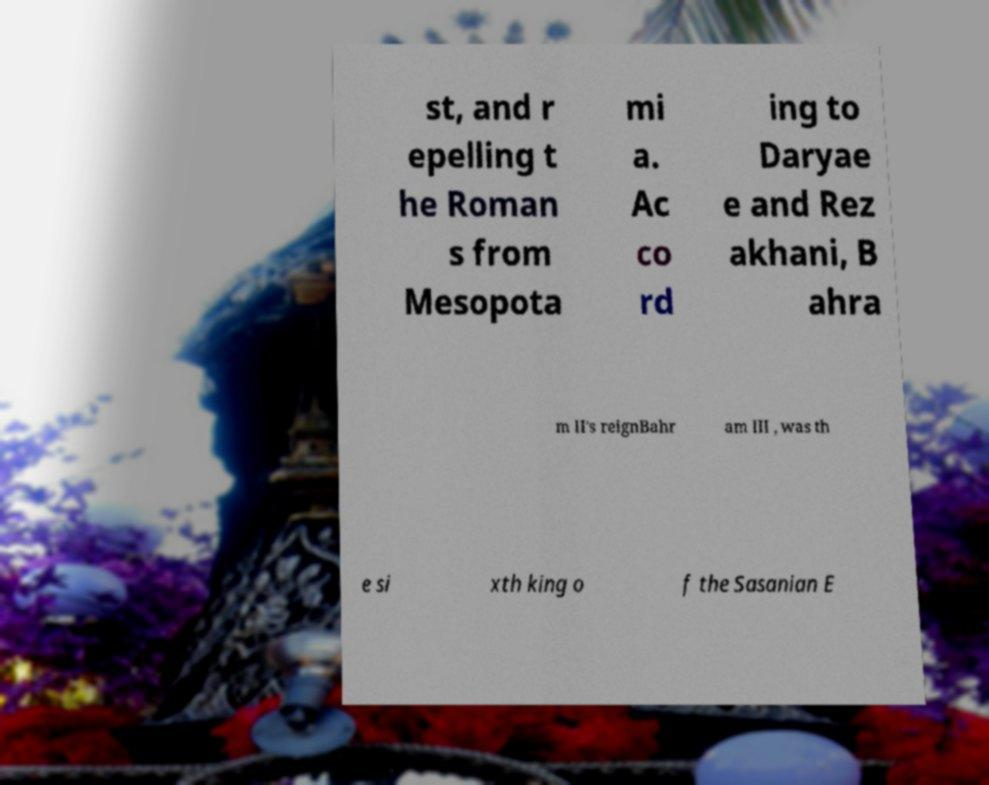Could you assist in decoding the text presented in this image and type it out clearly? st, and r epelling t he Roman s from Mesopota mi a. Ac co rd ing to Daryae e and Rez akhani, B ahra m II's reignBahr am III , was th e si xth king o f the Sasanian E 